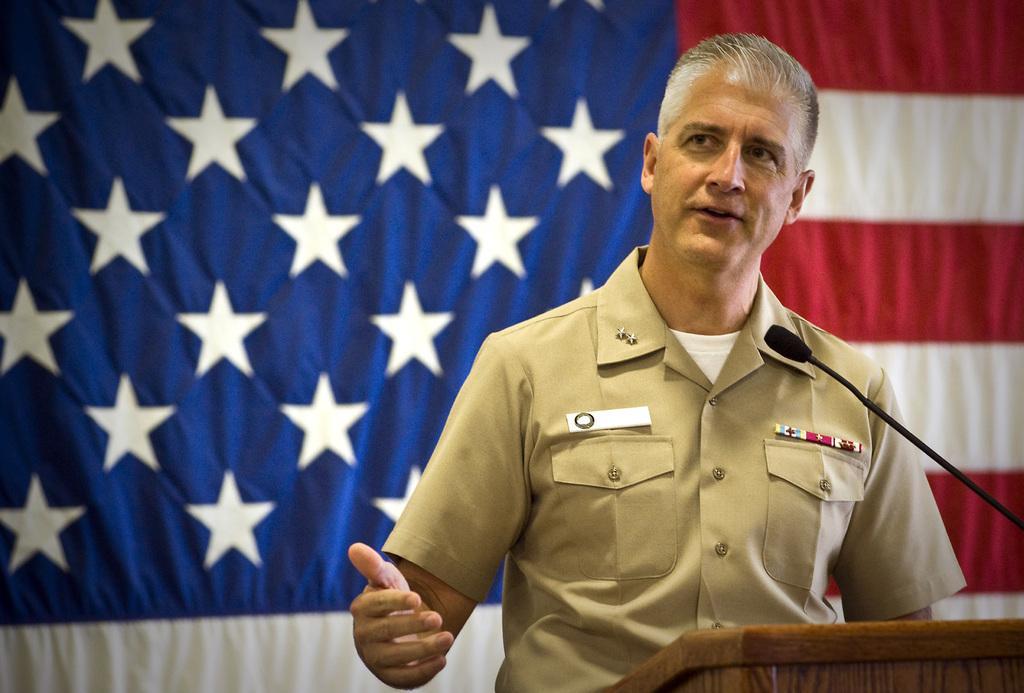Please provide a concise description of this image. This picture shows a man standing at a podium and speaking with the help of a microphone and we see a flag on the back and we see couple of badges on his shirt. 